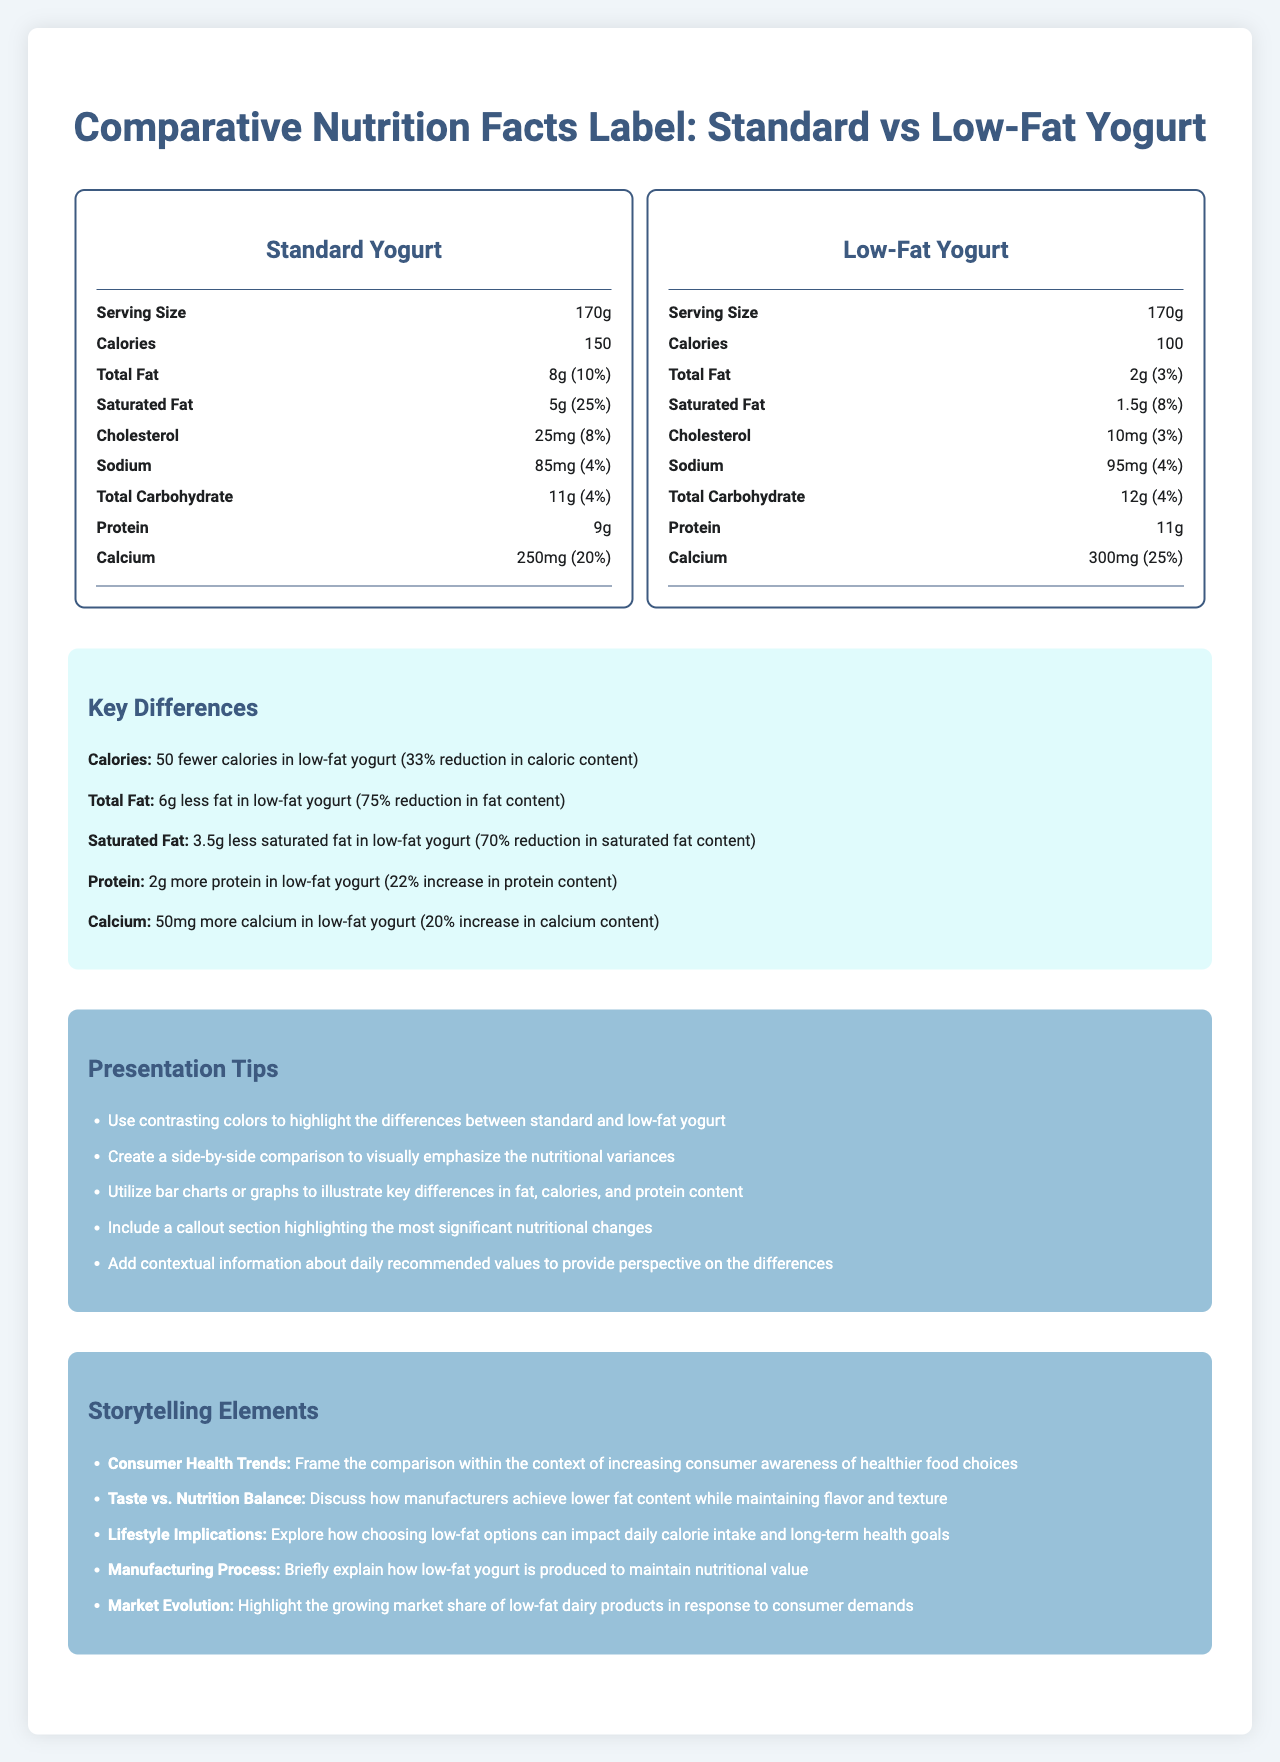what is the serving size for both yogurts? The serving size is listed as "170g" for both the standard and low-fat yogurts.
Answer: 170g how many calories are in the low-fat yogurt? The low-fat yogurt has 100 calories, as stated in the nutrition information under calories.
Answer: 100 calories by how much does the low-fat yogurt reduce the total fat content compared to the standard yogurt? The standard yogurt has 8g of total fat, whereas the low-fat yogurt has 2g, resulting in a 6g reduction.
Answer: 6g which yogurt has more protein? The low-fat yogurt has 11g of protein, while the standard yogurt has 9g of protein.
Answer: Low-fat yogurt how much calcium is there in the standard yogurt? The calcium content in the standard yogurt is 250mg, as noted in the nutrition facts.
Answer: 250mg what is the main idea of the document? The document provides a side-by-side comparison of the nutritional content of standard and low-fat yogurt to show how the low-fat option differs in key areas. Additionally, it presents tips for highlighting these differences in presentations, and discusses broader context and storytelling elements related to consumer preferences and health trends.
Answer: The document compares the nutrition facts of standard and low-fat yogurt, highlighting differences in calories, fat, protein, and other nutritional elements, and provides tips for effective presentation and storytelling techniques. which of the following items has the highest percentage daily value in the low-fat yogurt? 
A. Saturated Fat 
B. Calcium 
C. Sodium 
D. Cholesterol The low-fat yogurt's calcium content has a daily value percentage of 25%, which is higher than the others listed.
Answer: B based on the information provided, what potential impact could choosing low-fat yogurt have on your daily fat intake? 
A. Reduce total fat intake 
B. Increase total fat intake 
C. No change to fat intake Choosing low-fat yogurt could significantly reduce total fat intake, as it contains only 2g of fat compared to the 8g in standard yogurt.
Answer: A does the low-fat yogurt have more sodium than the standard yogurt? The low-fat yogurt contains 95mg of sodium compared to the standard yogurt's 85mg.
Answer: Yes is there any information on the iron content in both yogurts? Both yogurt types have 0mg of iron, as indicated in the nutrition facts labels.
Answer: Yes how much more calcium does the low-fat yogurt have compared to the standard yogurt? The low-fat yogurt contains 300mg of calcium, which is 50mg more than the 250mg in the standard yogurt.
Answer: 50mg what is the reduction percentage in calorie content when switching from standard to low-fat yogurt? The key differences section states a "33% reduction in caloric content" when switching from standard to low-fat yogurt, as the low-fat version has 50 fewer calories.
Answer: 33% reduction what is one recommended presentation tip for visually emphasizing nutritional differences? The presentation tips suggest using contrasting colors as an effective way to highlight the differences.
Answer: Use contrasting colors to highlight the differences between standard and low-fat yogurt. does the document explain how low-fat yogurt is produced? The document does not provide details about the production process of low-fat yogurt, though it briefly mentions it under the storytelling elements.
Answer: No according to the document, what storytelling element might be used to discuss the balance between taste and nutrition? The storytelling elements section mentions "Taste vs. Nutrition Balance" as a topic to discuss how manufacturers maintain flavor and texture while reducing fat content.
Answer: Taste vs. Nutrition Balance what is the percentage daily value of saturated fat in the standard yogurt? The standard yogurt has a saturated fat daily value percentage of 25%, as mentioned in the nutrition facts.
Answer: 25% 